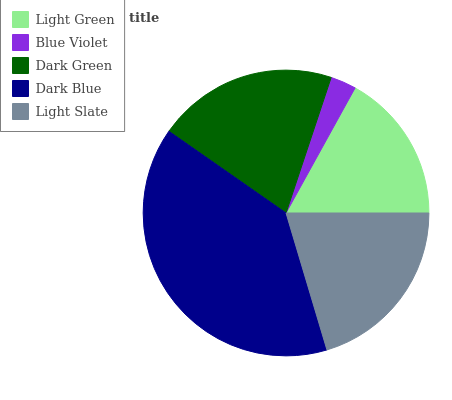Is Blue Violet the minimum?
Answer yes or no. Yes. Is Dark Blue the maximum?
Answer yes or no. Yes. Is Dark Green the minimum?
Answer yes or no. No. Is Dark Green the maximum?
Answer yes or no. No. Is Dark Green greater than Blue Violet?
Answer yes or no. Yes. Is Blue Violet less than Dark Green?
Answer yes or no. Yes. Is Blue Violet greater than Dark Green?
Answer yes or no. No. Is Dark Green less than Blue Violet?
Answer yes or no. No. Is Light Slate the high median?
Answer yes or no. Yes. Is Light Slate the low median?
Answer yes or no. Yes. Is Blue Violet the high median?
Answer yes or no. No. Is Light Green the low median?
Answer yes or no. No. 